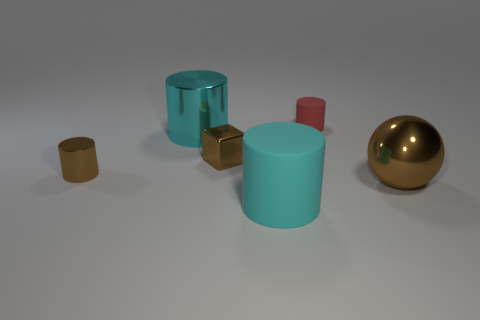How many cyan cylinders must be subtracted to get 1 cyan cylinders? 1 Add 2 small cyan matte cylinders. How many objects exist? 8 Subtract all cylinders. How many objects are left? 2 Subtract 0 green cylinders. How many objects are left? 6 Subtract all cyan cylinders. Subtract all small brown cubes. How many objects are left? 3 Add 4 tiny brown cylinders. How many tiny brown cylinders are left? 5 Add 5 purple cubes. How many purple cubes exist? 5 